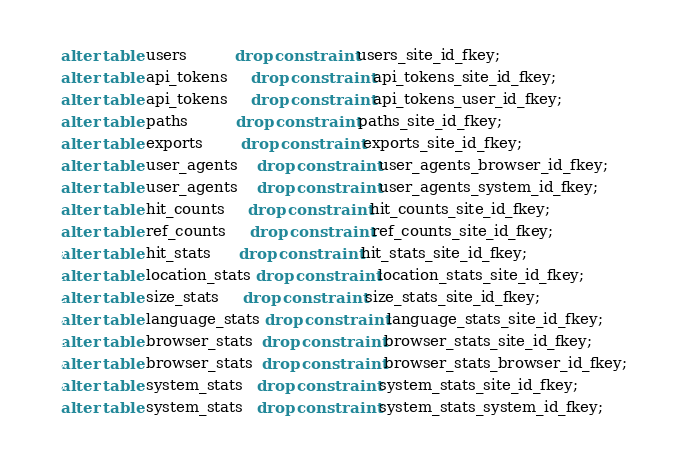Convert code to text. <code><loc_0><loc_0><loc_500><loc_500><_SQL_>alter table users          drop constraint users_site_id_fkey;
alter table api_tokens     drop constraint api_tokens_site_id_fkey;
alter table api_tokens     drop constraint api_tokens_user_id_fkey;
alter table paths          drop constraint paths_site_id_fkey;
alter table exports        drop constraint exports_site_id_fkey;
alter table user_agents    drop constraint user_agents_browser_id_fkey;
alter table user_agents    drop constraint user_agents_system_id_fkey;
alter table hit_counts     drop constraint hit_counts_site_id_fkey;
alter table ref_counts     drop constraint ref_counts_site_id_fkey;
alter table hit_stats      drop constraint hit_stats_site_id_fkey;
alter table location_stats drop constraint location_stats_site_id_fkey;
alter table size_stats     drop constraint size_stats_site_id_fkey;
alter table language_stats drop constraint language_stats_site_id_fkey;
alter table browser_stats  drop constraint browser_stats_site_id_fkey;
alter table browser_stats  drop constraint browser_stats_browser_id_fkey;
alter table system_stats   drop constraint system_stats_site_id_fkey;
alter table system_stats   drop constraint system_stats_system_id_fkey;
</code> 